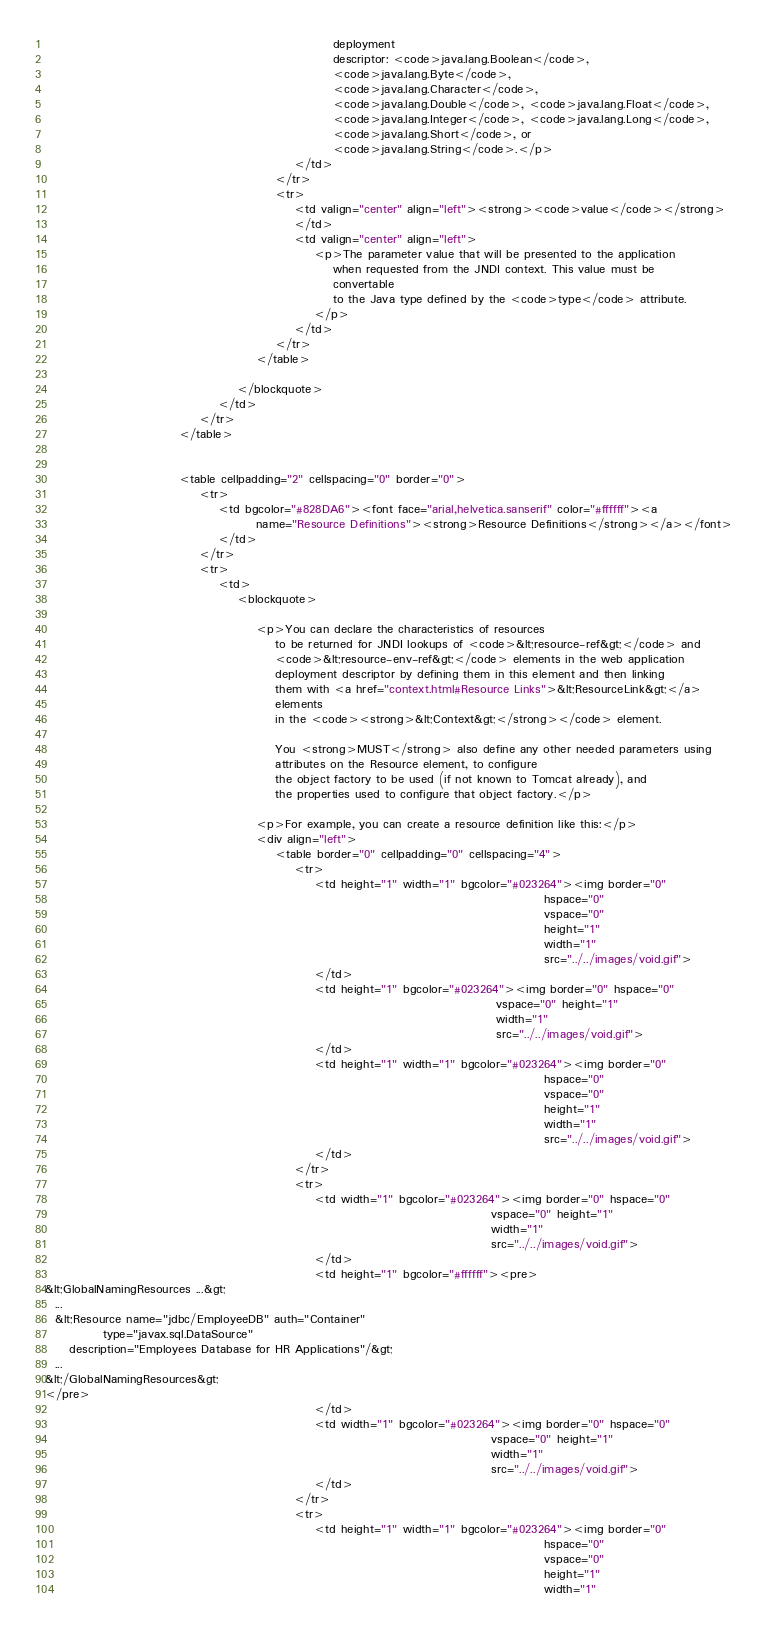Convert code to text. <code><loc_0><loc_0><loc_500><loc_500><_HTML_>                                                            deployment
                                                            descriptor: <code>java.lang.Boolean</code>,
                                                            <code>java.lang.Byte</code>,
                                                            <code>java.lang.Character</code>,
                                                            <code>java.lang.Double</code>, <code>java.lang.Float</code>,
                                                            <code>java.lang.Integer</code>, <code>java.lang.Long</code>,
                                                            <code>java.lang.Short</code>, or
                                                            <code>java.lang.String</code>.</p>
                                                    </td>
                                                </tr>
                                                <tr>
                                                    <td valign="center" align="left"><strong><code>value</code></strong>
                                                    </td>
                                                    <td valign="center" align="left">
                                                        <p>The parameter value that will be presented to the application
                                                            when requested from the JNDI context. This value must be
                                                            convertable
                                                            to the Java type defined by the <code>type</code> attribute.
                                                        </p>
                                                    </td>
                                                </tr>
                                            </table>

                                        </blockquote>
                                    </td>
                                </tr>
                            </table>


                            <table cellpadding="2" cellspacing="0" border="0">
                                <tr>
                                    <td bgcolor="#828DA6"><font face="arial,helvetica.sanserif" color="#ffffff"><a
                                            name="Resource Definitions"><strong>Resource Definitions</strong></a></font>
                                    </td>
                                </tr>
                                <tr>
                                    <td>
                                        <blockquote>

                                            <p>You can declare the characteristics of resources
                                                to be returned for JNDI lookups of <code>&lt;resource-ref&gt;</code> and
                                                <code>&lt;resource-env-ref&gt;</code> elements in the web application
                                                deployment descriptor by defining them in this element and then linking
                                                them with <a href="context.html#Resource Links">&lt;ResourceLink&gt;</a>
                                                elements
                                                in the <code><strong>&lt;Context&gt;</strong></code> element.

                                                You <strong>MUST</strong> also define any other needed parameters using
                                                attributes on the Resource element, to configure
                                                the object factory to be used (if not known to Tomcat already), and
                                                the properties used to configure that object factory.</p>

                                            <p>For example, you can create a resource definition like this:</p>
                                            <div align="left">
                                                <table border="0" cellpadding="0" cellspacing="4">
                                                    <tr>
                                                        <td height="1" width="1" bgcolor="#023264"><img border="0"
                                                                                                        hspace="0"
                                                                                                        vspace="0"
                                                                                                        height="1"
                                                                                                        width="1"
                                                                                                        src="../../images/void.gif">
                                                        </td>
                                                        <td height="1" bgcolor="#023264"><img border="0" hspace="0"
                                                                                              vspace="0" height="1"
                                                                                              width="1"
                                                                                              src="../../images/void.gif">
                                                        </td>
                                                        <td height="1" width="1" bgcolor="#023264"><img border="0"
                                                                                                        hspace="0"
                                                                                                        vspace="0"
                                                                                                        height="1"
                                                                                                        width="1"
                                                                                                        src="../../images/void.gif">
                                                        </td>
                                                    </tr>
                                                    <tr>
                                                        <td width="1" bgcolor="#023264"><img border="0" hspace="0"
                                                                                             vspace="0" height="1"
                                                                                             width="1"
                                                                                             src="../../images/void.gif">
                                                        </td>
                                                        <td height="1" bgcolor="#ffffff"><pre>
&lt;GlobalNamingResources ...&gt;
  ...
  &lt;Resource name="jdbc/EmployeeDB" auth="Container"
            type="javax.sql.DataSource"
     description="Employees Database for HR Applications"/&gt;
  ...
&lt;/GlobalNamingResources&gt;
</pre>
                                                        </td>
                                                        <td width="1" bgcolor="#023264"><img border="0" hspace="0"
                                                                                             vspace="0" height="1"
                                                                                             width="1"
                                                                                             src="../../images/void.gif">
                                                        </td>
                                                    </tr>
                                                    <tr>
                                                        <td height="1" width="1" bgcolor="#023264"><img border="0"
                                                                                                        hspace="0"
                                                                                                        vspace="0"
                                                                                                        height="1"
                                                                                                        width="1"</code> 